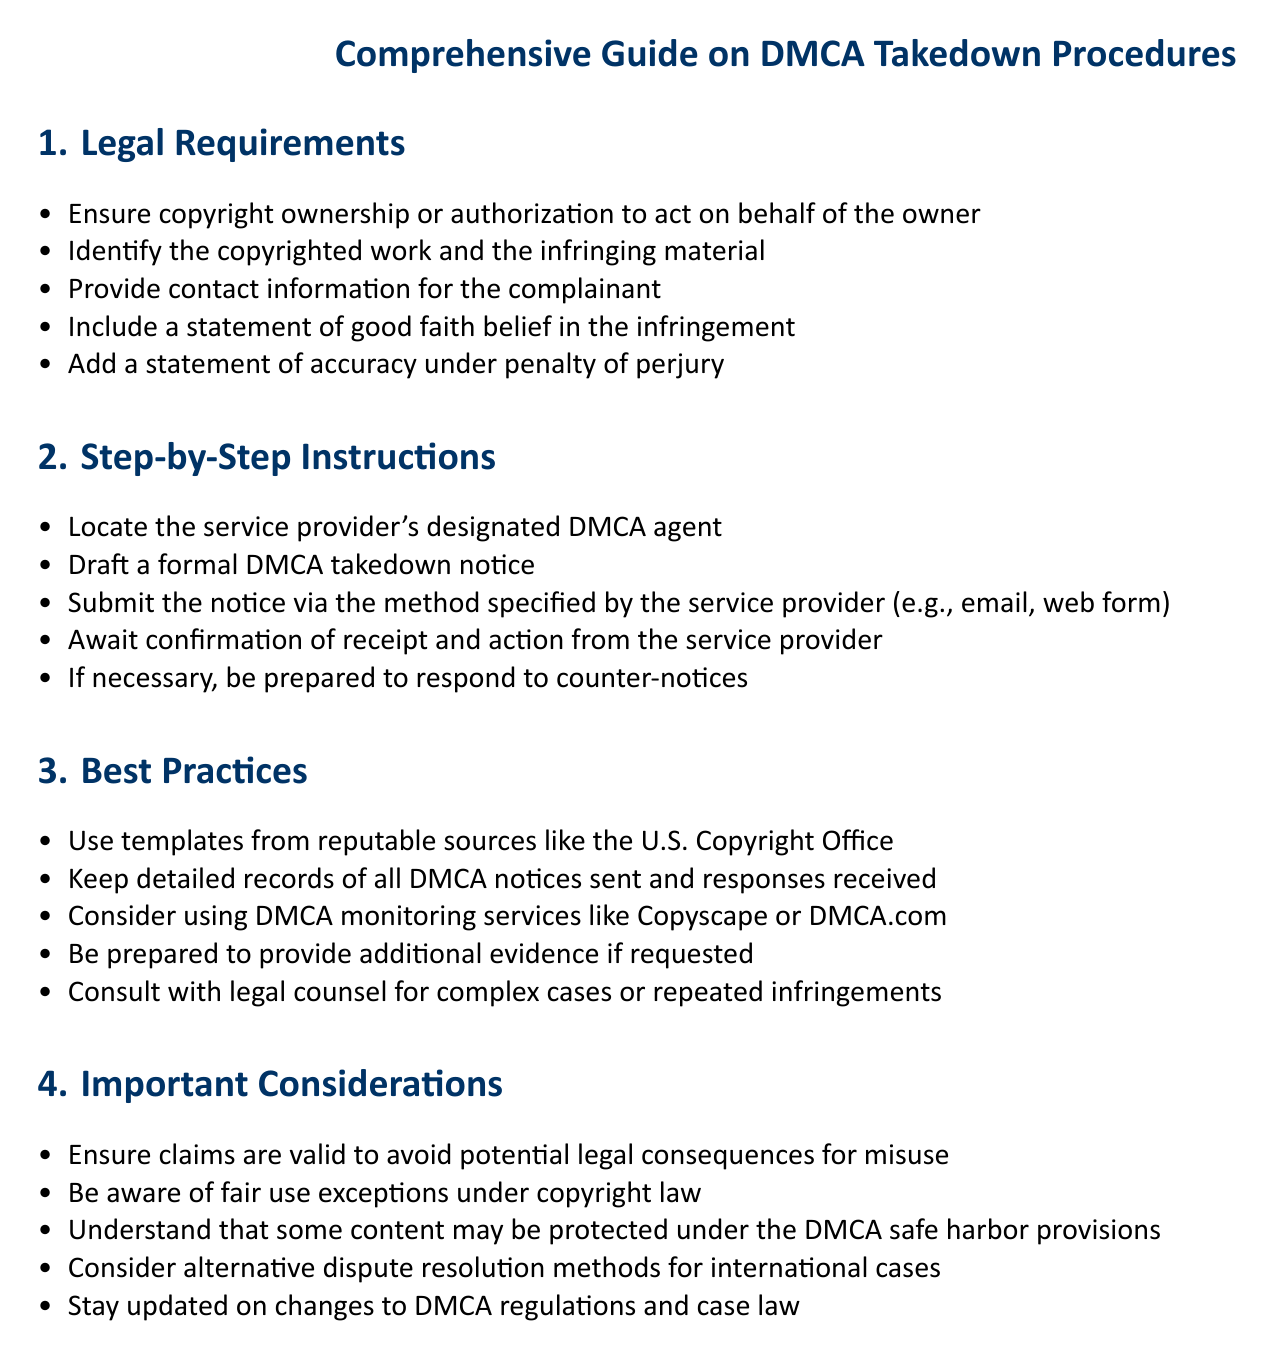What are the legal requirements for a DMCA complaint? The legal requirements are outlined in section 1 of the document, which lists five specific items that must be included in a DMCA takedown notice.
Answer: copyright ownership, identification of copyrighted work and infringing material, contact information, statement of good faith, accuracy statement How many step-by-step instructions are provided? The document lists five specific step-by-step instructions under section 2 for filing a DMCA takedown notice.
Answer: five What is the purpose of the ‘Best Practices’ section? Section 3 is focused on strategies to enhance the effectiveness and compliance of DMCA takedown notices.
Answer: Effective DMCA notices What should you be prepared to do if a counter-notice is received? According to step 5 in section 2, you should be prepared to respond if necessary.
Answer: Respond to counter-notices What is a recommended source for DMCA notice templates? The document mentions the U.S. Copyright Office as a reputable source for templates in section 3.
Answer: U.S. Copyright Office What is one important consideration under section 4? This section includes warnings about the validity of claims and potential legal consequences to avoid misuse.
Answer: Valid claims What should be monitored in international cases according to the document? The document suggests considering alternative dispute resolution methods for addressing international cases in section 4.
Answer: Alternative dispute resolution methods What is the main theme of section 4 in the document? This section addresses important considerations regarding DMCA takedown procedures and legal implications related to copyright.
Answer: Important considerations 